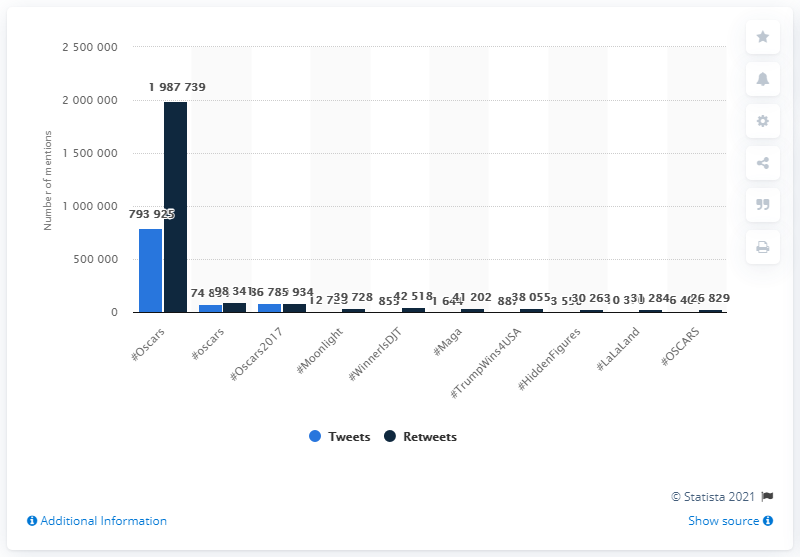Outline some significant characteristics in this image. The top mentioned hashtag on Twitter during the Oscars was #Moonlight. The hashtag #LaLaLand appeared on Twitter 10,370 times during the same period. 